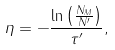<formula> <loc_0><loc_0><loc_500><loc_500>\eta = - \frac { \ln { \left ( \frac { N _ { M } } { N ^ { \prime } } \right ) } } { \tau ^ { \prime } } ,</formula> 